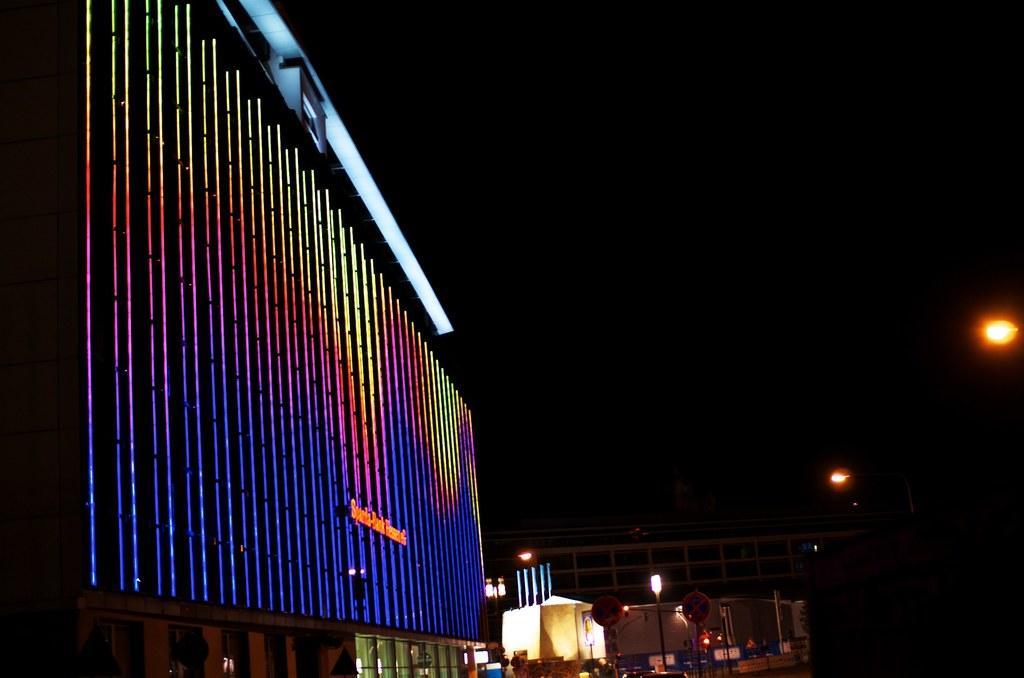Could you give a brief overview of what you see in this image? In this image we can see the buildings with lights and text. We can see the street lights, board, boxes and dark background. 